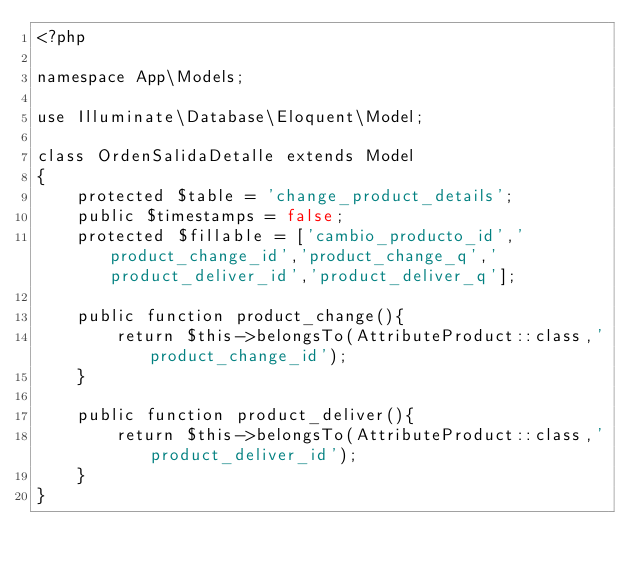Convert code to text. <code><loc_0><loc_0><loc_500><loc_500><_PHP_><?php

namespace App\Models;

use Illuminate\Database\Eloquent\Model;

class OrdenSalidaDetalle extends Model
{
    protected $table = 'change_product_details';
    public $timestamps = false;
    protected $fillable = ['cambio_producto_id','product_change_id','product_change_q','product_deliver_id','product_deliver_q'];

    public function product_change(){
        return $this->belongsTo(AttributeProduct::class,'product_change_id');
    }

    public function product_deliver(){
        return $this->belongsTo(AttributeProduct::class,'product_deliver_id');
    }
}
</code> 